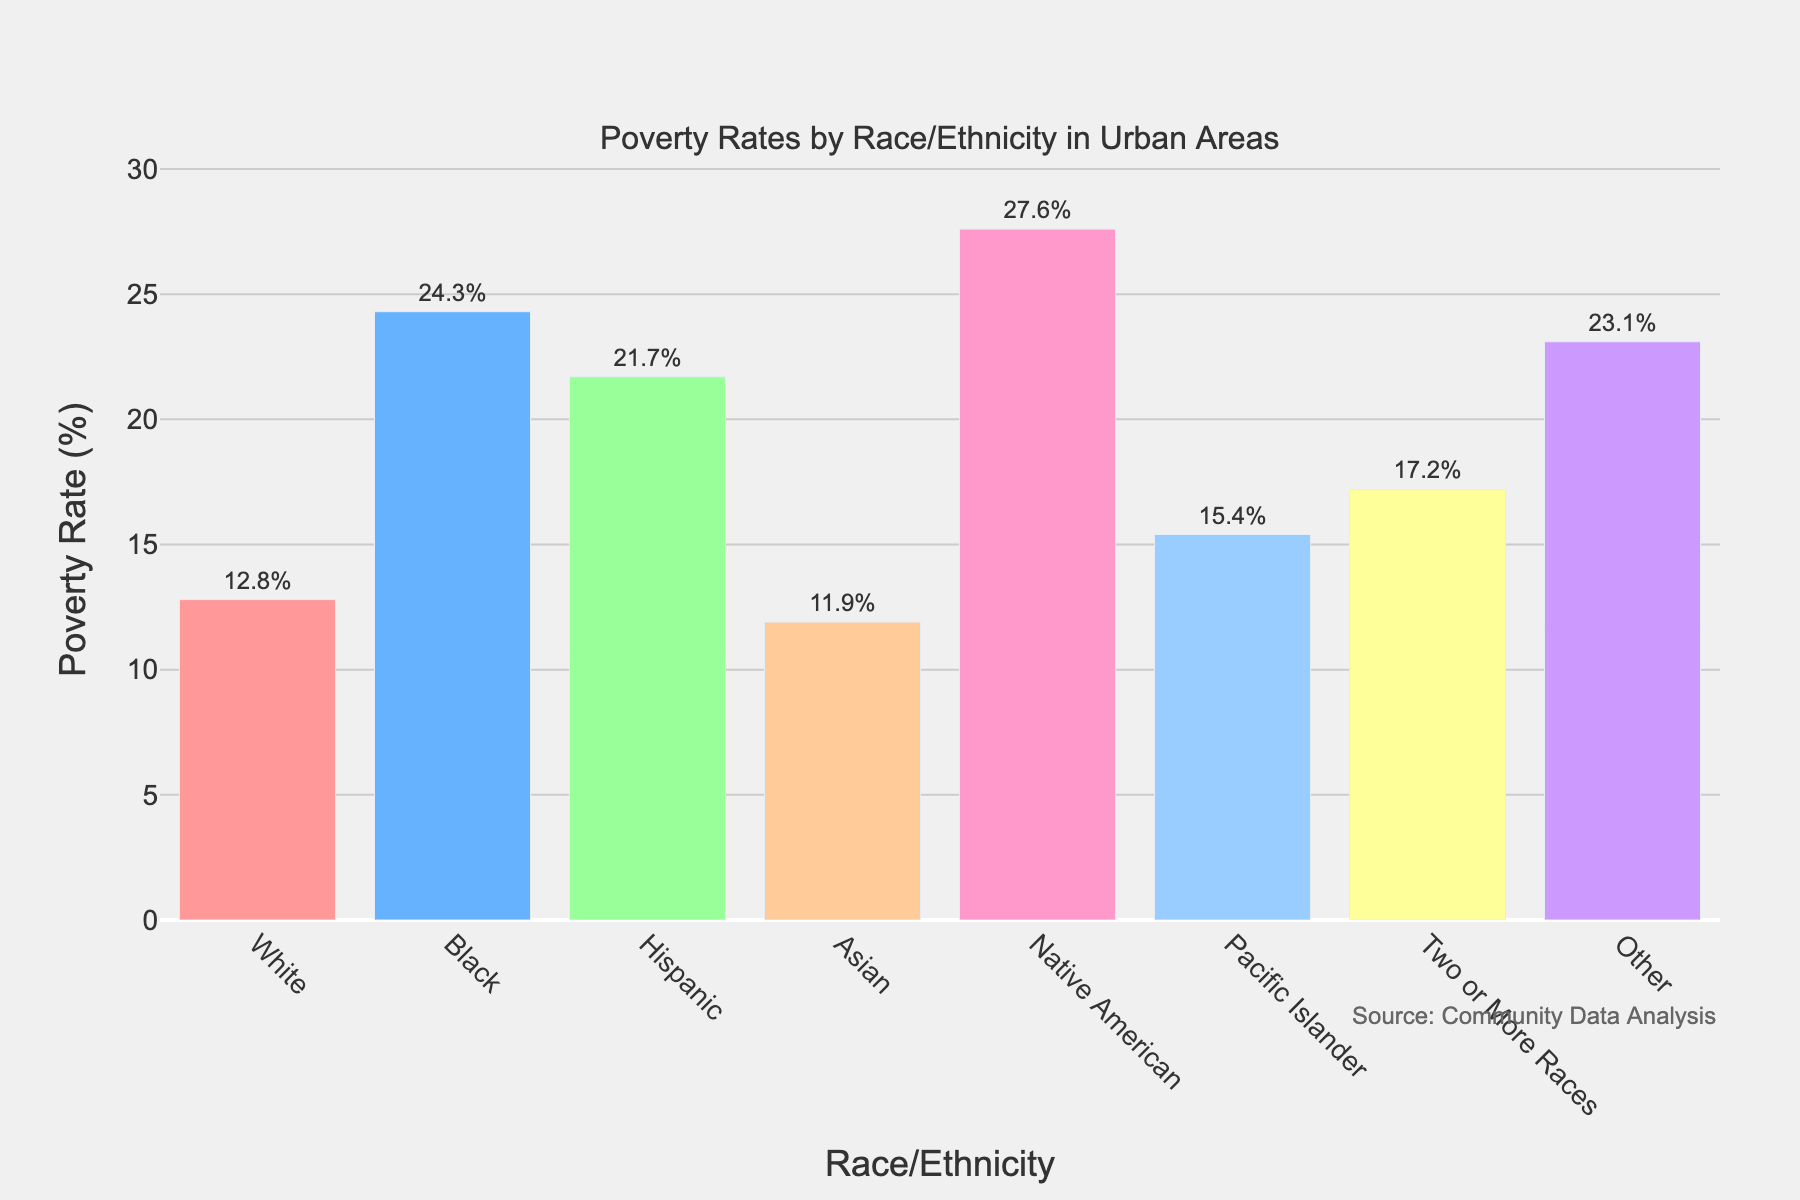What is the poverty rate for Native Americans? The bar labeled "Native American" shows a height corresponding to 27.6%, indicating this group's poverty rate.
Answer: 27.6% Which racial/ethnic group has the lowest poverty rate? The bar for "Asian" appears shortest in the figure, corresponding to the lowest poverty rate, which is 11.9%.
Answer: Asian Compare the poverty rates of Black and Pacific Islander groups. Who has a higher rate? By comparing the heights of the bars for "Black" and "Pacific Islander," the "Black" bar is taller, indicating a higher poverty rate of 24.3% compared to 15.4% for "Pacific Islander."
Answer: Black What is the difference in the poverty rate between White and Hispanic groups? The poverty rate for Whites is 12.8% and for Hispanics is 21.7%. Subtracting 12.8 from 21.7 gives a difference of 8.9%.
Answer: 8.9% What is the total poverty rate combining the White, Asian, and Two or More Races groups? Adding the poverty rates of White (12.8%), Asian (11.9%), and Two or More Races (17.2%) results in 12.8 + 11.9 + 17.2 = 41.9%.
Answer: 41.9% Explain the visual difference between the bar for "Other" and the bar for "Hispanic." The bar for "Other" has a poverty rate of 23.1% and is slightly shorter than the bar for "Hispanic," which has a poverty rate of 21.7%.
Answer: Other bar is slightly taller What is the average poverty rate for all the groups shown in the chart? The average can be found by summing the poverty rates and dividing by the number of groups. The total is 12.8 + 24.3 + 21.7 + 11.9 + 27.6 + 15.4 + 17.2 + 23.1 = 154%. Dividing by 8 groups gives an average of 154/8 = 19.25%.
Answer: 19.25% Which group is represented by the third tallest bar in the chart? By visually comparing bar heights, the "Other" group's poverty rate of 23.1%, makes it the third tallest bar.
Answer: Other What is the range of poverty rates in the groups shown? The highest poverty rate is 27.6% (Native American) and the lowest is 11.9% (Asian). The range is 27.6 - 11.9 = 15.7%.
Answer: 15.7% 